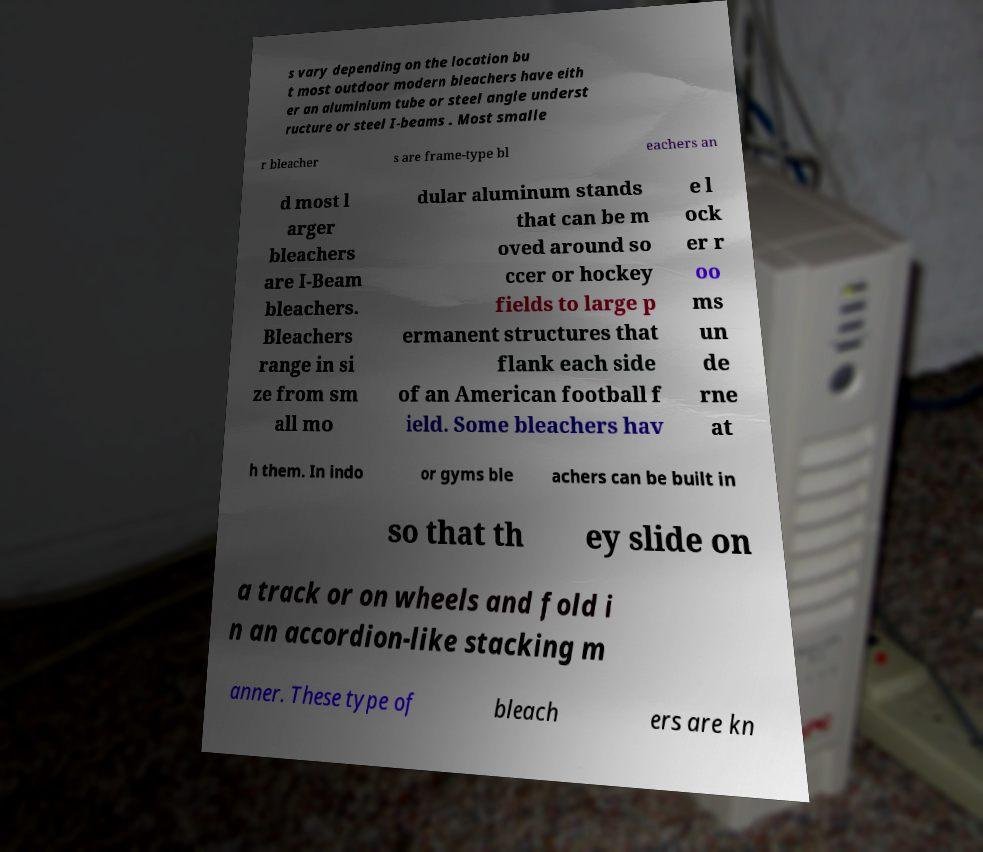What messages or text are displayed in this image? I need them in a readable, typed format. s vary depending on the location bu t most outdoor modern bleachers have eith er an aluminium tube or steel angle underst ructure or steel I-beams . Most smalle r bleacher s are frame-type bl eachers an d most l arger bleachers are I-Beam bleachers. Bleachers range in si ze from sm all mo dular aluminum stands that can be m oved around so ccer or hockey fields to large p ermanent structures that flank each side of an American football f ield. Some bleachers hav e l ock er r oo ms un de rne at h them. In indo or gyms ble achers can be built in so that th ey slide on a track or on wheels and fold i n an accordion-like stacking m anner. These type of bleach ers are kn 